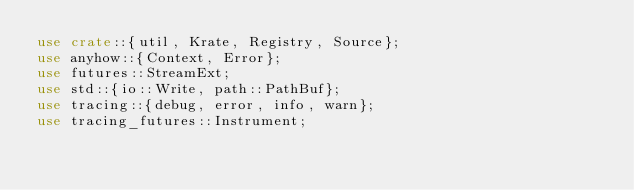Convert code to text. <code><loc_0><loc_0><loc_500><loc_500><_Rust_>use crate::{util, Krate, Registry, Source};
use anyhow::{Context, Error};
use futures::StreamExt;
use std::{io::Write, path::PathBuf};
use tracing::{debug, error, info, warn};
use tracing_futures::Instrument;
</code> 